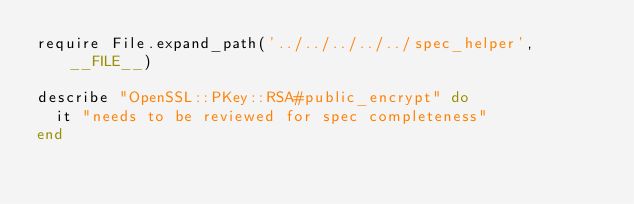<code> <loc_0><loc_0><loc_500><loc_500><_Ruby_>require File.expand_path('../../../../../spec_helper', __FILE__)

describe "OpenSSL::PKey::RSA#public_encrypt" do
  it "needs to be reviewed for spec completeness"
end
</code> 